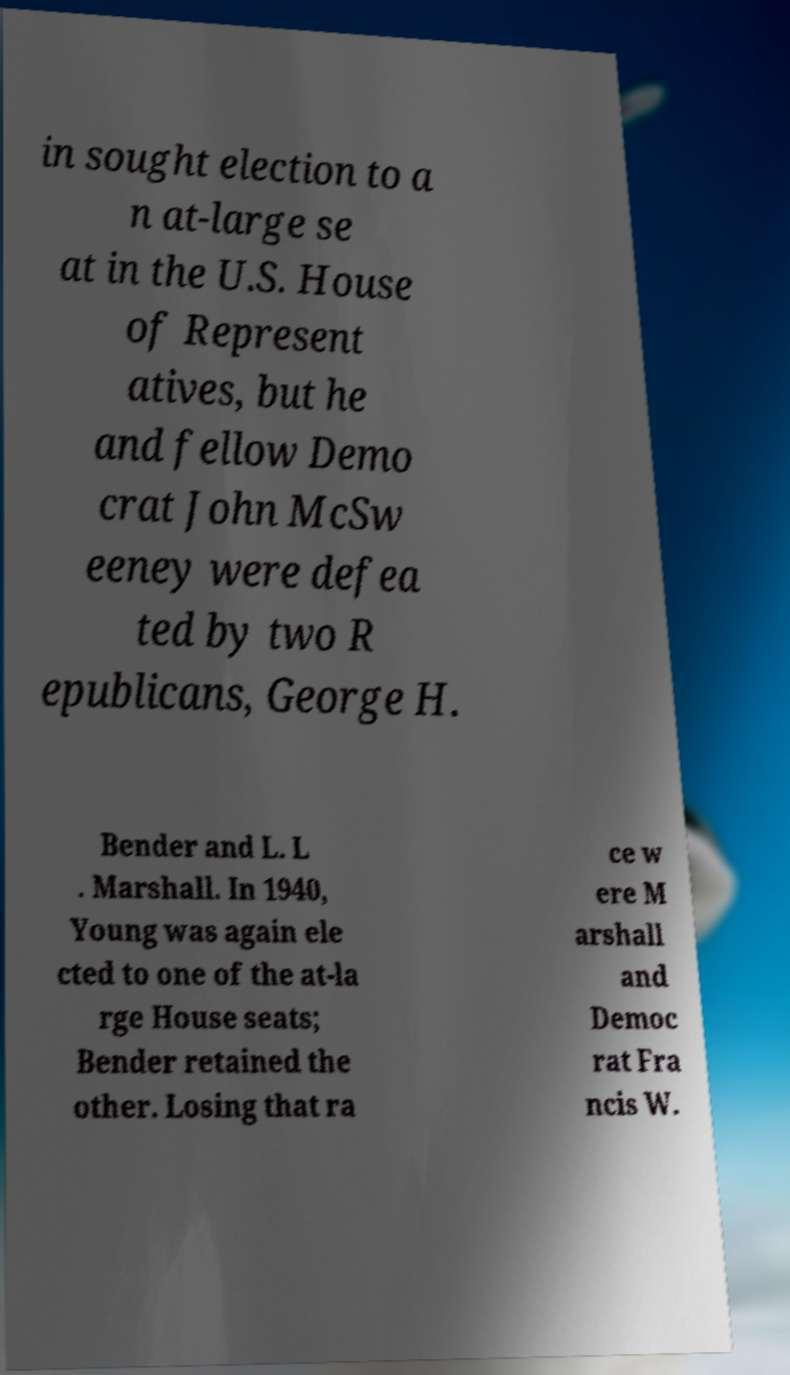There's text embedded in this image that I need extracted. Can you transcribe it verbatim? in sought election to a n at-large se at in the U.S. House of Represent atives, but he and fellow Demo crat John McSw eeney were defea ted by two R epublicans, George H. Bender and L. L . Marshall. In 1940, Young was again ele cted to one of the at-la rge House seats; Bender retained the other. Losing that ra ce w ere M arshall and Democ rat Fra ncis W. 